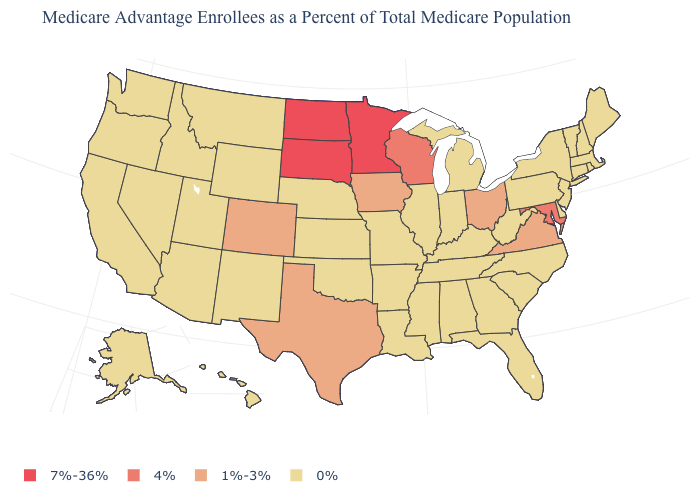What is the highest value in the USA?
Be succinct. 7%-36%. What is the value of New Jersey?
Keep it brief. 0%. Name the states that have a value in the range 1%-3%?
Concise answer only. Colorado, Iowa, Ohio, Texas, Virginia. What is the lowest value in the USA?
Give a very brief answer. 0%. What is the value of New Hampshire?
Be succinct. 0%. Name the states that have a value in the range 7%-36%?
Give a very brief answer. Minnesota, North Dakota, South Dakota. What is the value of New York?
Concise answer only. 0%. What is the value of Washington?
Be succinct. 0%. Which states have the highest value in the USA?
Keep it brief. Minnesota, North Dakota, South Dakota. What is the value of Arizona?
Quick response, please. 0%. Name the states that have a value in the range 7%-36%?
Be succinct. Minnesota, North Dakota, South Dakota. Does South Carolina have a lower value than New Jersey?
Give a very brief answer. No. What is the value of Oregon?
Answer briefly. 0%. What is the value of Alaska?
Concise answer only. 0%. 